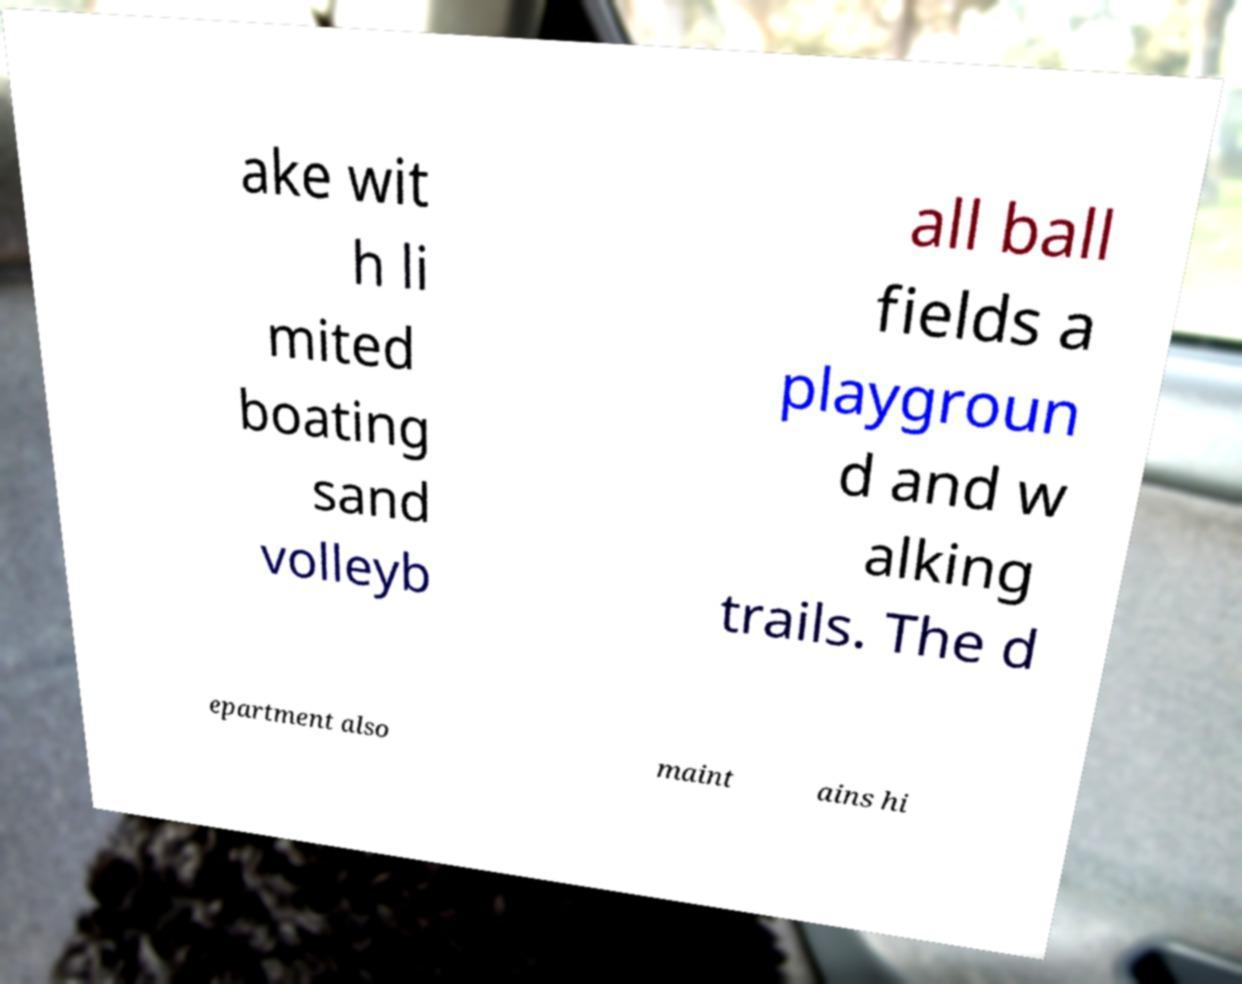Please identify and transcribe the text found in this image. ake wit h li mited boating sand volleyb all ball fields a playgroun d and w alking trails. The d epartment also maint ains hi 